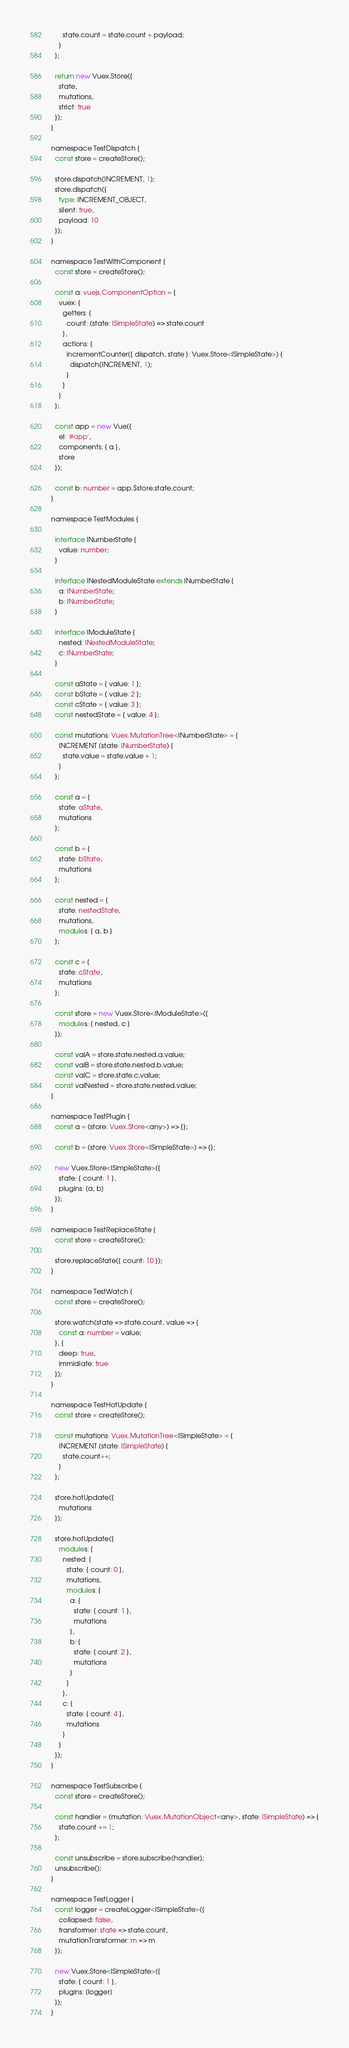Convert code to text. <code><loc_0><loc_0><loc_500><loc_500><_TypeScript_>      state.count = state.count + payload;
    }
  };

  return new Vuex.Store({
    state,
    mutations,
    strict: true
  });
}

namespace TestDispatch {
  const store = createStore();

  store.dispatch(INCREMENT, 1);
  store.dispatch({
    type: INCREMENT_OBJECT,
    silent: true,
    payload: 10
  });
}

namespace TestWithComponent {
  const store = createStore();

  const a: vuejs.ComponentOption = {
    vuex: {
      getters: {
        count: (state: ISimpleState) => state.count
      },
      actions: {
        incrementCounter({ dispatch, state }: Vuex.Store<ISimpleState>) {
          dispatch(INCREMENT, 1);
        }
      }
    }
  };

  const app = new Vue({
    el: '#app',
    components: { a },
    store
  });

  const b: number = app.$store.state.count;
}

namespace TestModules {

  interface INumberState {
    value: number;
  }

  interface INestedModuleState extends INumberState {
    a: INumberState;
    b: INumberState;
  }

  interface IModuleState {
    nested: INestedModuleState;
    c: INumberState;
  }

  const aState = { value: 1 };
  const bState = { value: 2 };
  const cState = { value: 3 };
  const nestedState = { value: 4 };

  const mutations: Vuex.MutationTree<INumberState> = {
    INCREMENT (state: INumberState) {
      state.value = state.value + 1;
    }
  };

  const a = {
    state: aState,
    mutations
  };

  const b = {
    state: bState,
    mutations
  };

  const nested = {
    state: nestedState,
    mutations,
    modules: { a, b }
  };

  const c = {
    state: cState,
    mutations
  };

  const store = new Vuex.Store<IModuleState>({
    modules: { nested, c }
  });

  const valA = store.state.nested.a.value;
  const valB = store.state.nested.b.value;
  const valC = store.state.c.value;
  const valNested = store.state.nested.value;
}

namespace TestPlugin {
  const a = (store: Vuex.Store<any>) => {};

  const b = (store: Vuex.Store<ISimpleState>) => {};

  new Vuex.Store<ISimpleState>({
    state: { count: 1 },
    plugins: [a, b]
  });
}

namespace TestReplaceState {
  const store = createStore();

  store.replaceState({ count: 10 });
}

namespace TestWatch {
  const store = createStore();

  store.watch(state => state.count, value => {
    const a: number = value;
  }, {
    deep: true,
    immidiate: true
  });
}

namespace TestHotUpdate {
  const store = createStore();

  const mutations: Vuex.MutationTree<ISimpleState> = {
    INCREMENT (state: ISimpleState) {
      state.count++;
    }
  };

  store.hotUpdate({
    mutations
  });

  store.hotUpdate({
    modules: {
      nested: {
        state: { count: 0 },
        mutations,
        modules: {
          a: {
            state: { count: 1 },
            mutations
          },
          b: {
            state: { count: 2 },
            mutations
          }
        }
      },
      c: {
        state: { count: 4 },
        mutations
      }
    }
  });
}

namespace TestSubscribe {
  const store = createStore();

  const handler = (mutation: Vuex.MutationObject<any>, state: ISimpleState) => {
    state.count += 1;
  };

  const unsubscribe = store.subscribe(handler);
  unsubscribe();
}

namespace TestLogger {
  const logger = createLogger<ISimpleState>({
    collapsed: false,
    transformer: state => state.count,
    mutationTransformer: m => m
  });

  new Vuex.Store<ISimpleState>({
    state: { count: 1 },
    plugins: [logger]
  });
}
</code> 